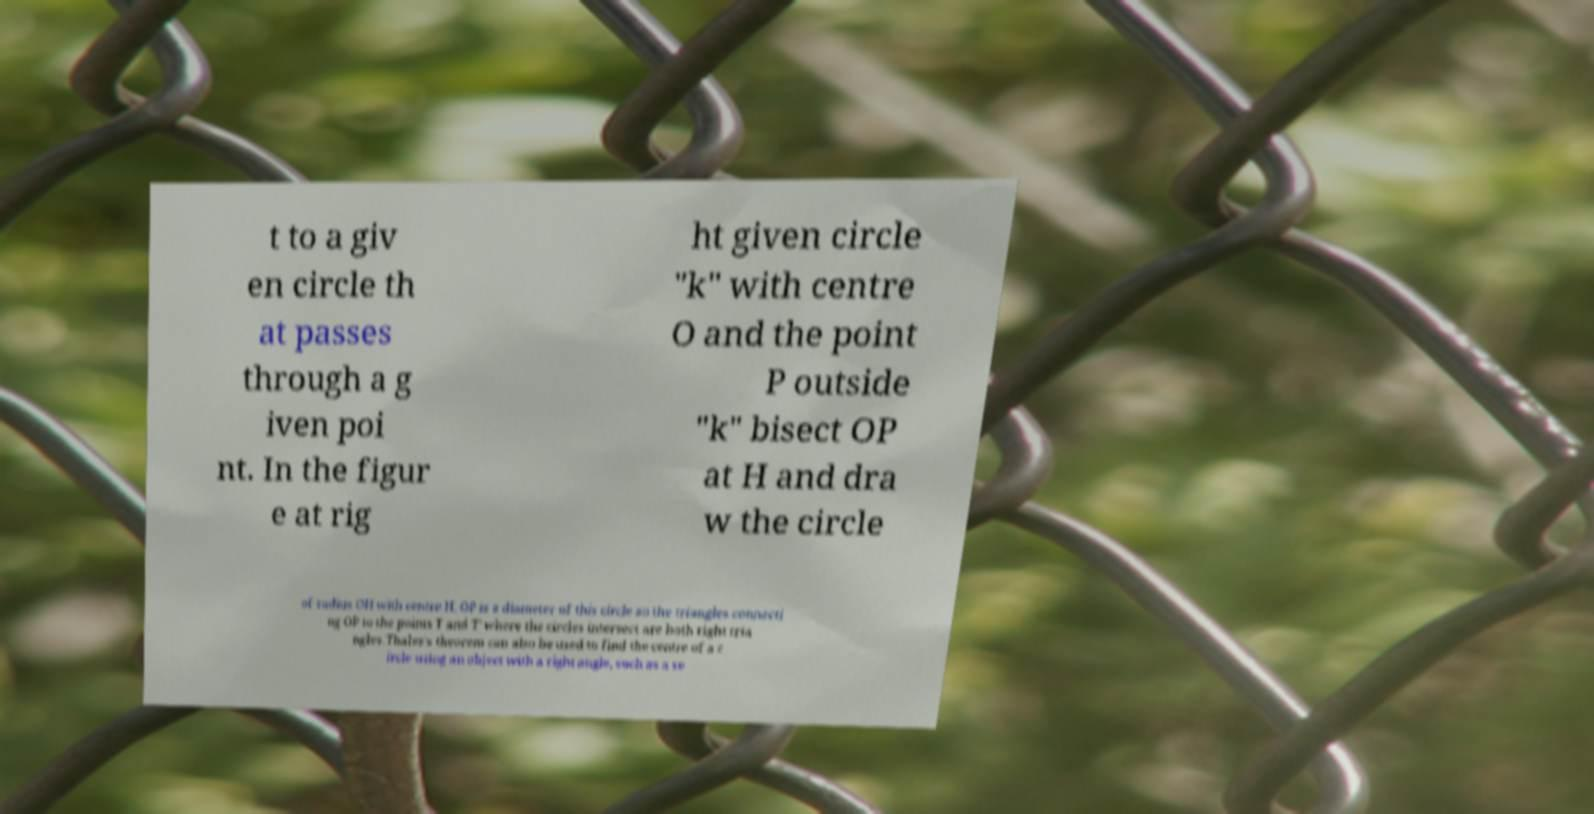Please read and relay the text visible in this image. What does it say? t to a giv en circle th at passes through a g iven poi nt. In the figur e at rig ht given circle "k" with centre O and the point P outside "k" bisect OP at H and dra w the circle of radius OH with centre H. OP is a diameter of this circle so the triangles connecti ng OP to the points T and T′ where the circles intersect are both right tria ngles.Thales's theorem can also be used to find the centre of a c ircle using an object with a right angle, such as a se 